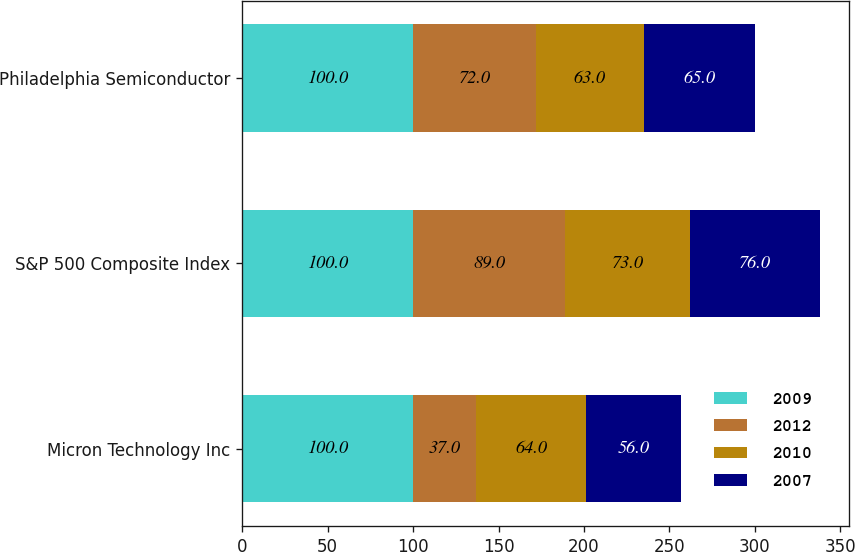Convert chart to OTSL. <chart><loc_0><loc_0><loc_500><loc_500><stacked_bar_chart><ecel><fcel>Micron Technology Inc<fcel>S&P 500 Composite Index<fcel>Philadelphia Semiconductor<nl><fcel>2009<fcel>100<fcel>100<fcel>100<nl><fcel>2012<fcel>37<fcel>89<fcel>72<nl><fcel>2010<fcel>64<fcel>73<fcel>63<nl><fcel>2007<fcel>56<fcel>76<fcel>65<nl></chart> 